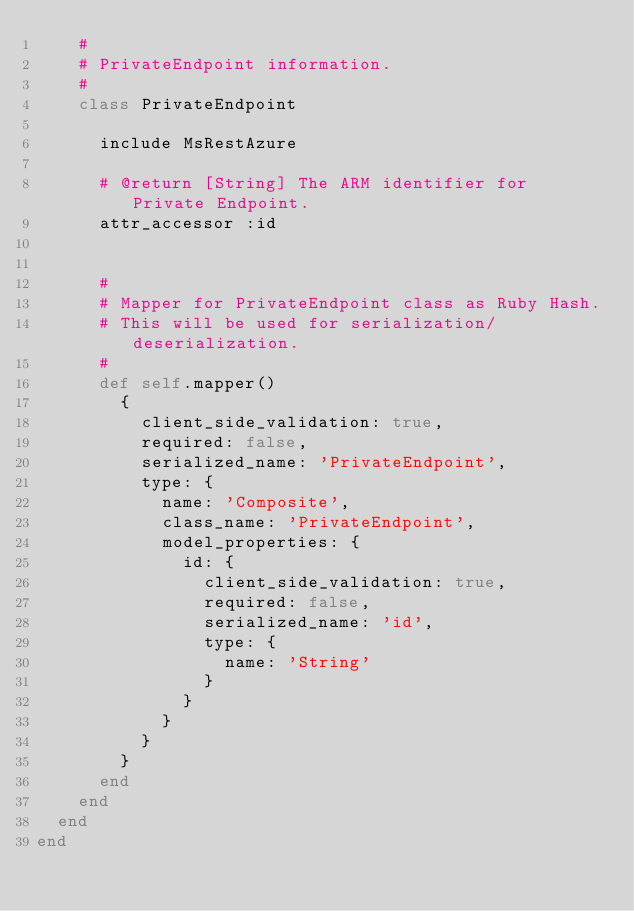<code> <loc_0><loc_0><loc_500><loc_500><_Ruby_>    #
    # PrivateEndpoint information.
    #
    class PrivateEndpoint

      include MsRestAzure

      # @return [String] The ARM identifier for Private Endpoint.
      attr_accessor :id


      #
      # Mapper for PrivateEndpoint class as Ruby Hash.
      # This will be used for serialization/deserialization.
      #
      def self.mapper()
        {
          client_side_validation: true,
          required: false,
          serialized_name: 'PrivateEndpoint',
          type: {
            name: 'Composite',
            class_name: 'PrivateEndpoint',
            model_properties: {
              id: {
                client_side_validation: true,
                required: false,
                serialized_name: 'id',
                type: {
                  name: 'String'
                }
              }
            }
          }
        }
      end
    end
  end
end
</code> 